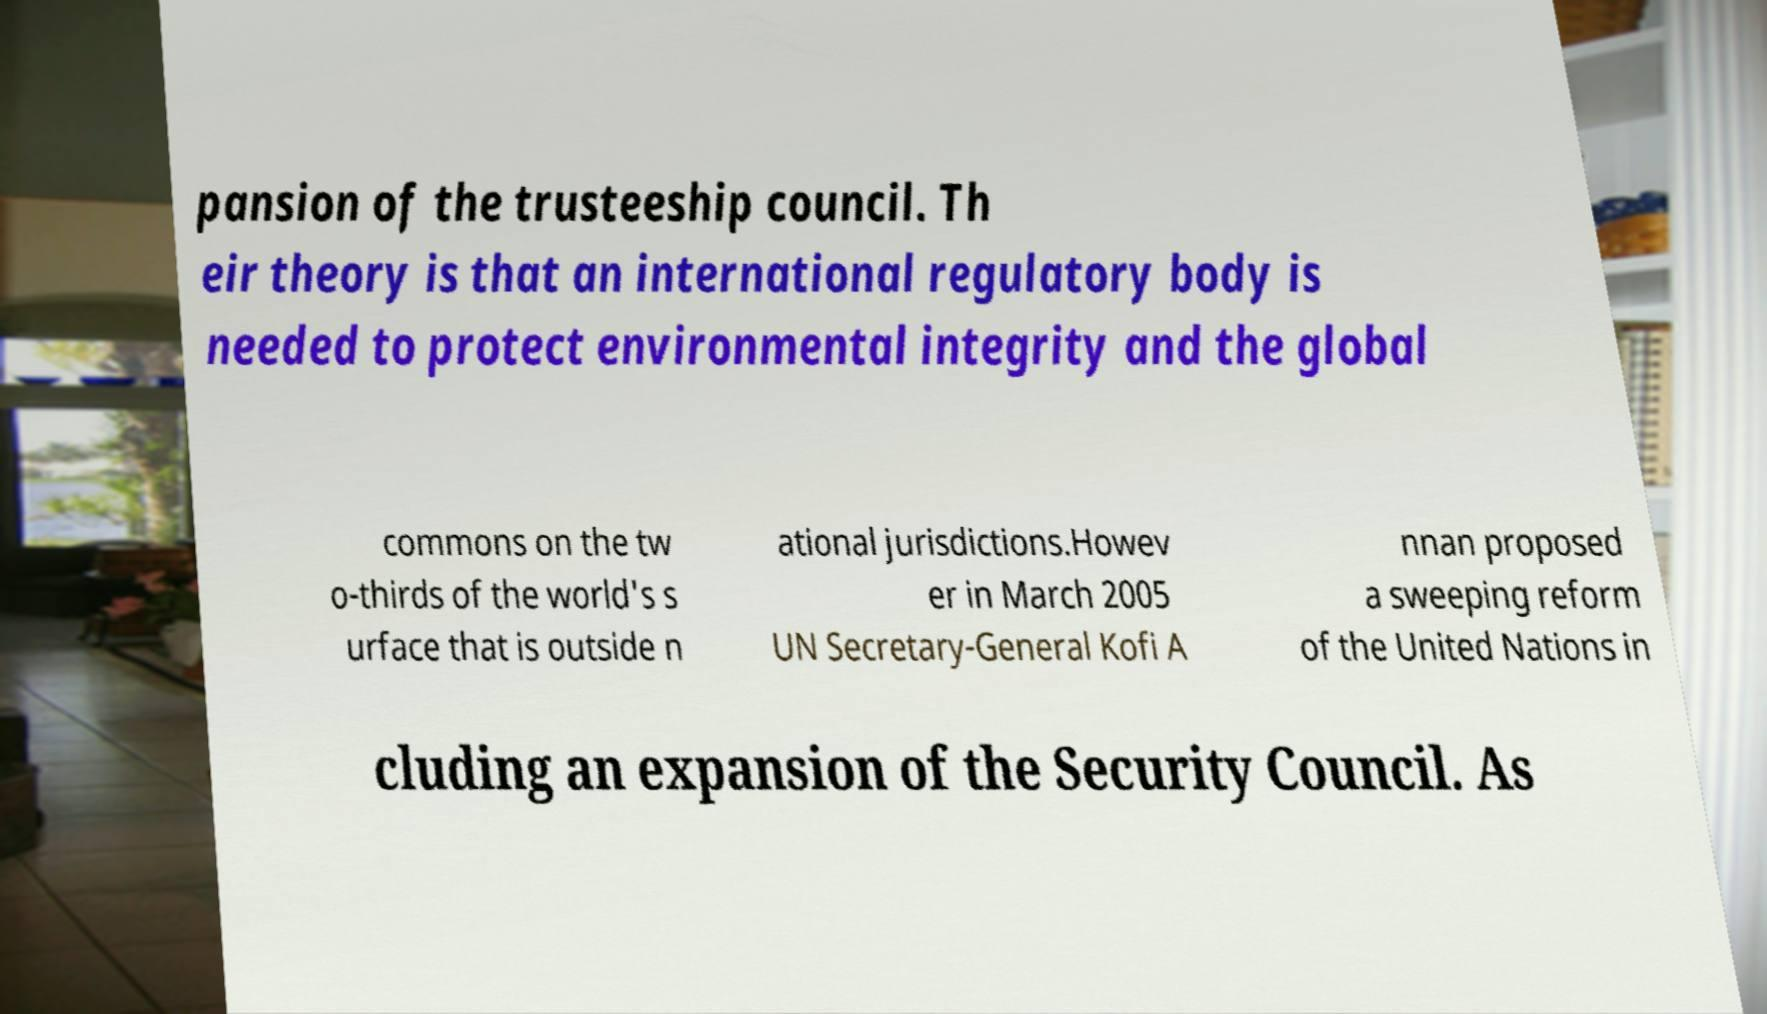Could you extract and type out the text from this image? pansion of the trusteeship council. Th eir theory is that an international regulatory body is needed to protect environmental integrity and the global commons on the tw o-thirds of the world's s urface that is outside n ational jurisdictions.Howev er in March 2005 UN Secretary-General Kofi A nnan proposed a sweeping reform of the United Nations in cluding an expansion of the Security Council. As 